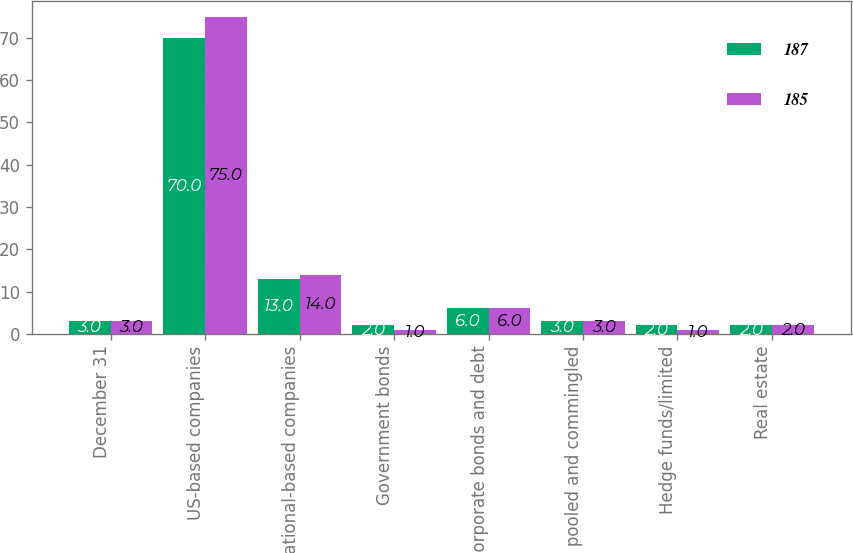<chart> <loc_0><loc_0><loc_500><loc_500><stacked_bar_chart><ecel><fcel>December 31<fcel>US-based companies<fcel>International-based companies<fcel>Government bonds<fcel>Corporate bonds and debt<fcel>Mutual pooled and commingled<fcel>Hedge funds/limited<fcel>Real estate<nl><fcel>187<fcel>3<fcel>70<fcel>13<fcel>2<fcel>6<fcel>3<fcel>2<fcel>2<nl><fcel>185<fcel>3<fcel>75<fcel>14<fcel>1<fcel>6<fcel>3<fcel>1<fcel>2<nl></chart> 